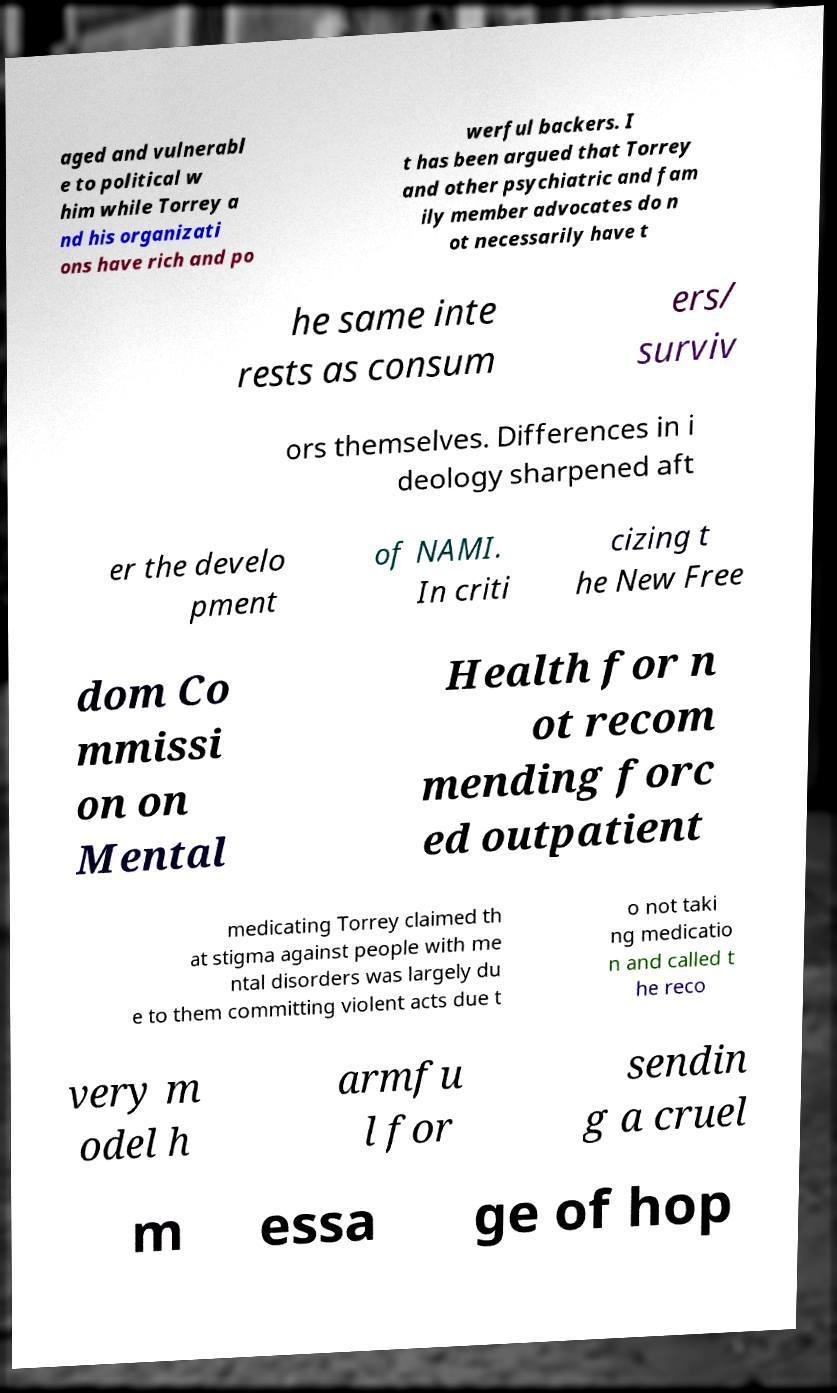Please identify and transcribe the text found in this image. aged and vulnerabl e to political w him while Torrey a nd his organizati ons have rich and po werful backers. I t has been argued that Torrey and other psychiatric and fam ily member advocates do n ot necessarily have t he same inte rests as consum ers/ surviv ors themselves. Differences in i deology sharpened aft er the develo pment of NAMI. In criti cizing t he New Free dom Co mmissi on on Mental Health for n ot recom mending forc ed outpatient medicating Torrey claimed th at stigma against people with me ntal disorders was largely du e to them committing violent acts due t o not taki ng medicatio n and called t he reco very m odel h armfu l for sendin g a cruel m essa ge of hop 